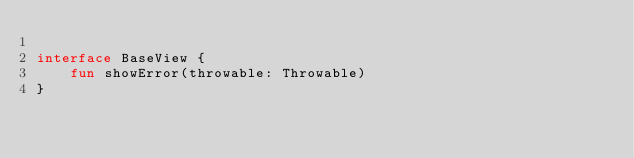Convert code to text. <code><loc_0><loc_0><loc_500><loc_500><_Kotlin_>
interface BaseView {
    fun showError(throwable: Throwable)
}</code> 